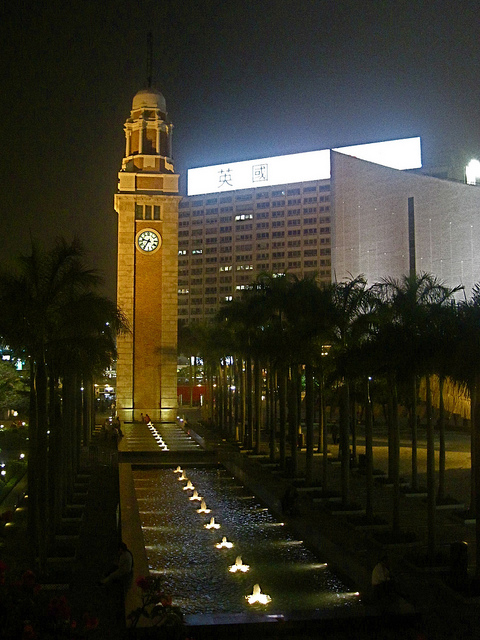<image>Are there kids around? No, there are no kids around. Are there kids around? There are no kids around. 